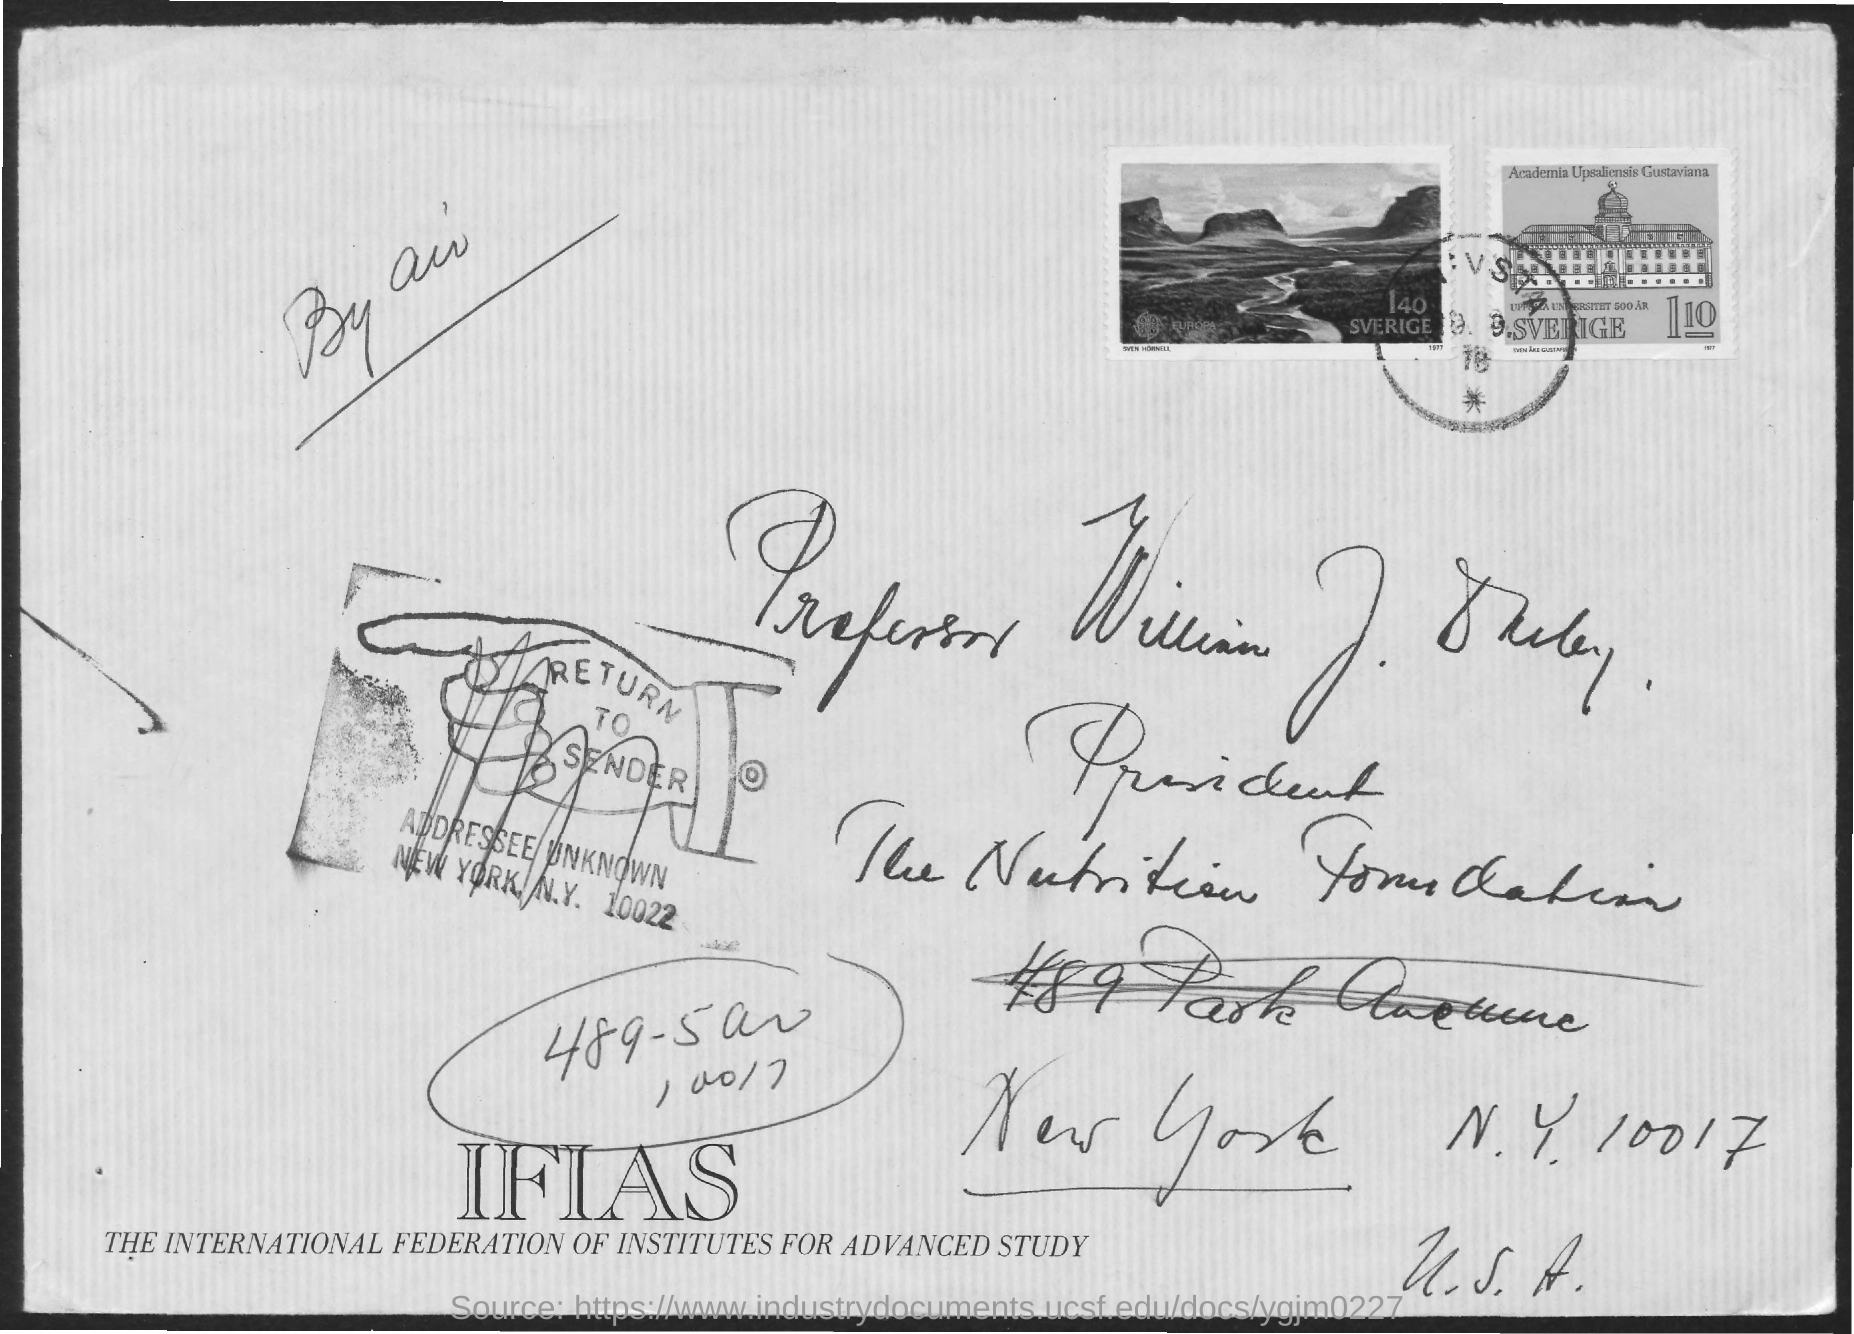Outline some significant characteristics in this image. The post mentioned the name of a president. The International Federation of Institutes for Advanced Study, commonly referred to as IFIAS, is an organization dedicated to promoting advanced research and scholarly exchange among its member institutes. The envelope is addressed to Professor William J. Darby. The envelope was posted by air. The zipcode specified is 10017. 